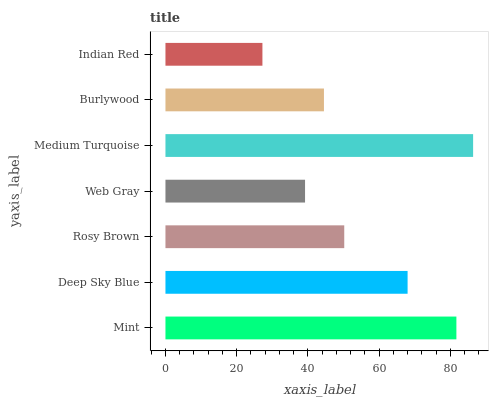Is Indian Red the minimum?
Answer yes or no. Yes. Is Medium Turquoise the maximum?
Answer yes or no. Yes. Is Deep Sky Blue the minimum?
Answer yes or no. No. Is Deep Sky Blue the maximum?
Answer yes or no. No. Is Mint greater than Deep Sky Blue?
Answer yes or no. Yes. Is Deep Sky Blue less than Mint?
Answer yes or no. Yes. Is Deep Sky Blue greater than Mint?
Answer yes or no. No. Is Mint less than Deep Sky Blue?
Answer yes or no. No. Is Rosy Brown the high median?
Answer yes or no. Yes. Is Rosy Brown the low median?
Answer yes or no. Yes. Is Web Gray the high median?
Answer yes or no. No. Is Medium Turquoise the low median?
Answer yes or no. No. 